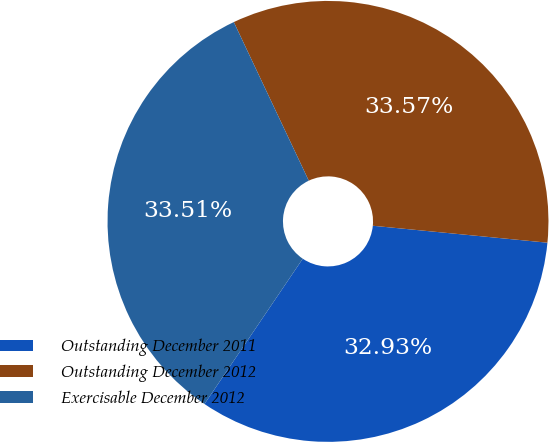<chart> <loc_0><loc_0><loc_500><loc_500><pie_chart><fcel>Outstanding December 2011<fcel>Outstanding December 2012<fcel>Exercisable December 2012<nl><fcel>32.93%<fcel>33.57%<fcel>33.51%<nl></chart> 